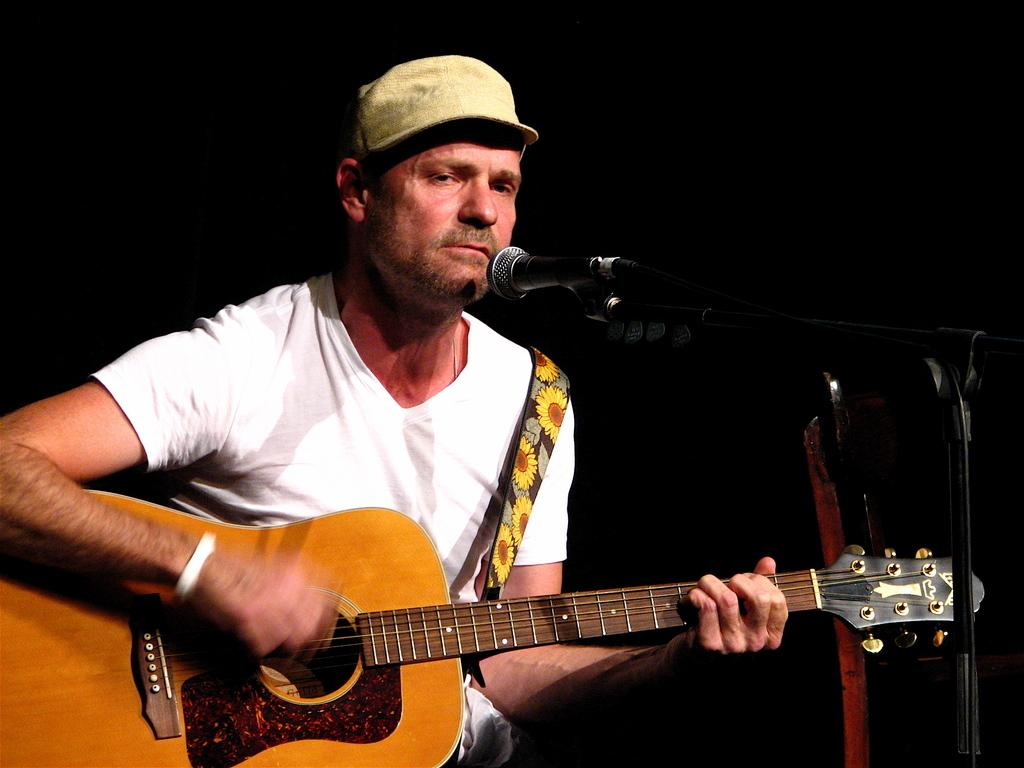What is the main subject of the image? The main subject of the image is a man. What is the man doing in the image? The man is sitting and playing a guitar. What type of drum is the man playing in the image? There is no drum present in the image; the man is playing a guitar. Can you tell me how many yokes are visible in the image? There are no yokes present in the image. 